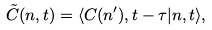<formula> <loc_0><loc_0><loc_500><loc_500>\tilde { C } ( n , t ) = \langle C ( n ^ { \prime } ) , { t - \tau } | n , t \rangle ,</formula> 